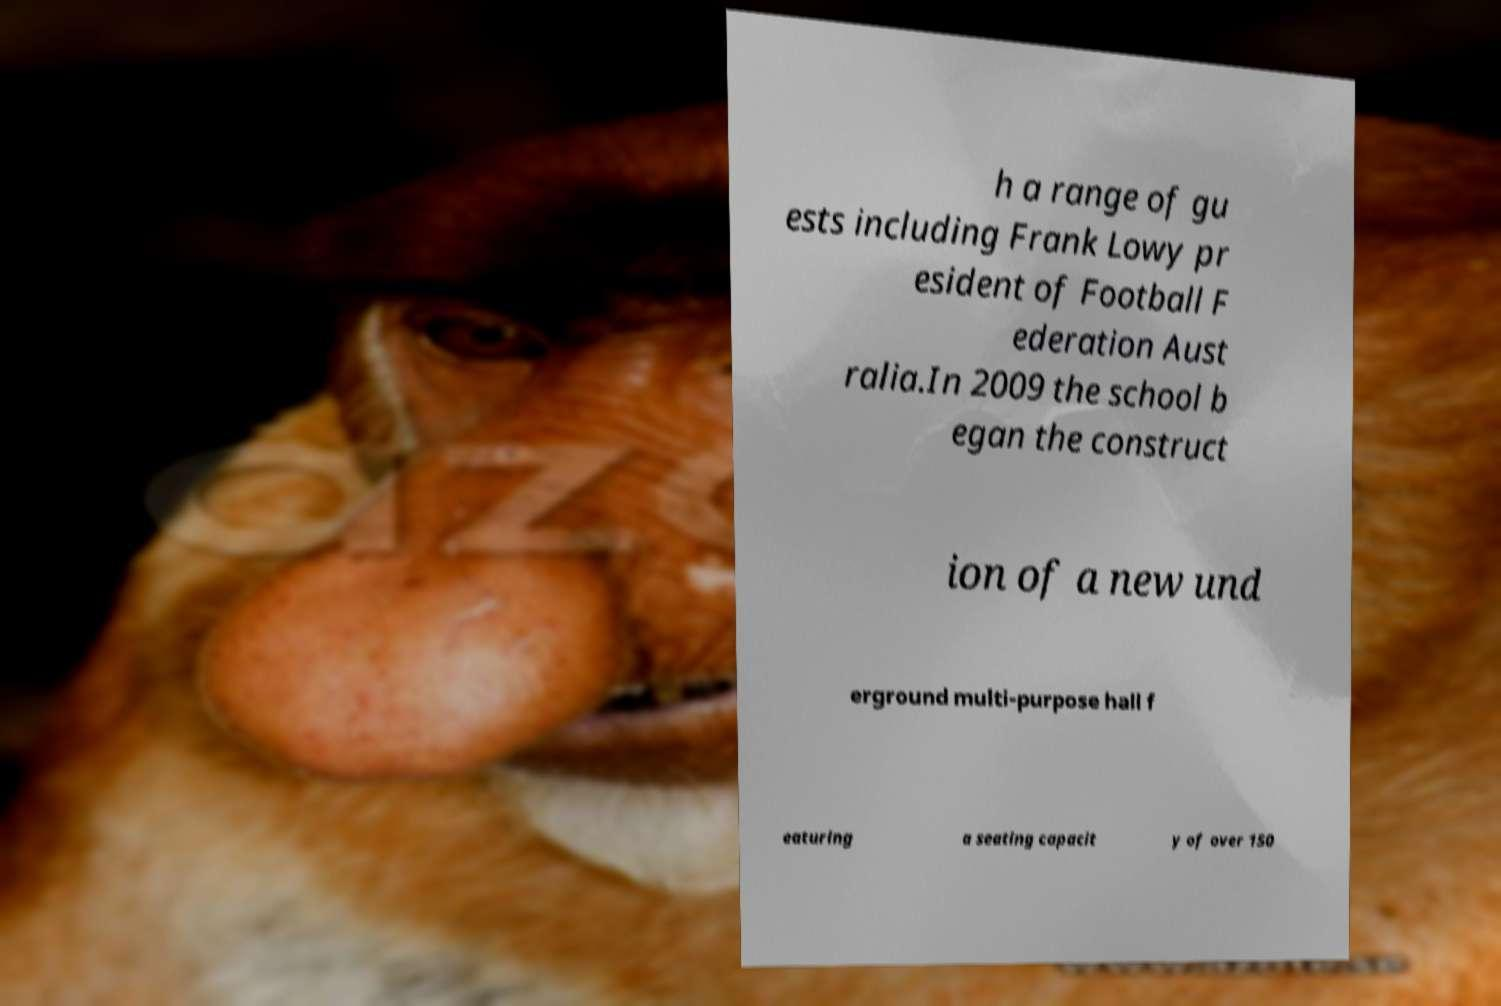Could you extract and type out the text from this image? h a range of gu ests including Frank Lowy pr esident of Football F ederation Aust ralia.In 2009 the school b egan the construct ion of a new und erground multi-purpose hall f eaturing a seating capacit y of over 150 